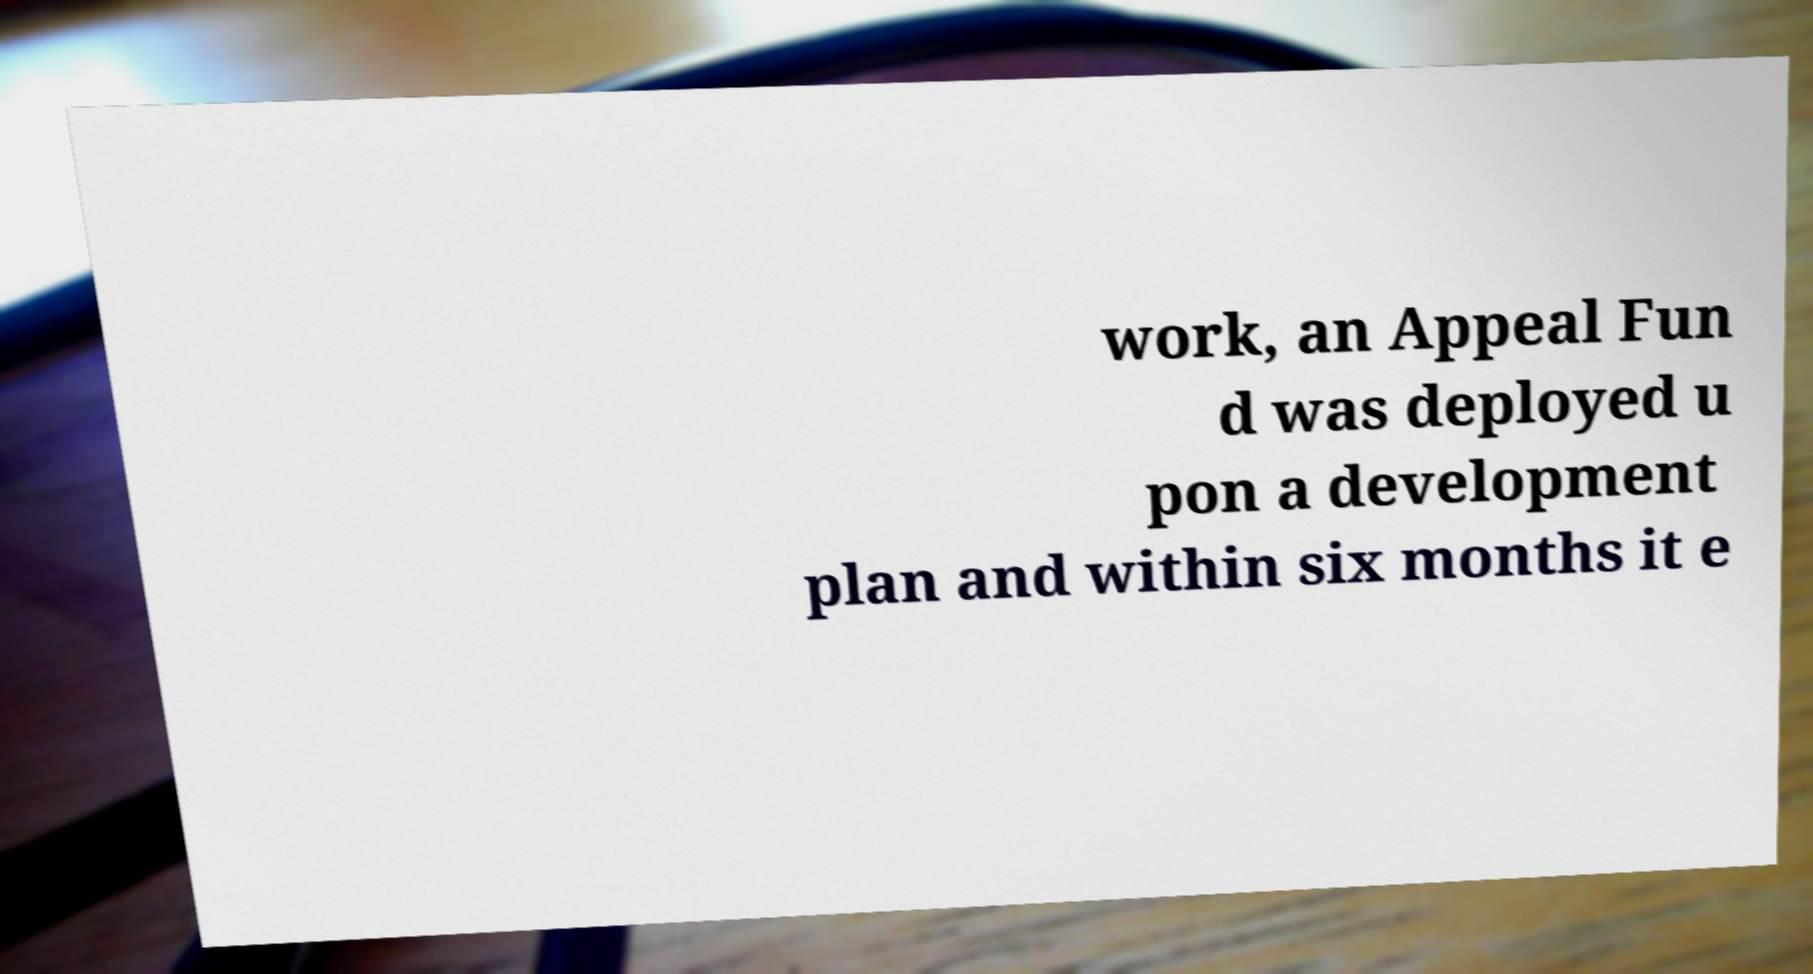For documentation purposes, I need the text within this image transcribed. Could you provide that? work, an Appeal Fun d was deployed u pon a development plan and within six months it e 